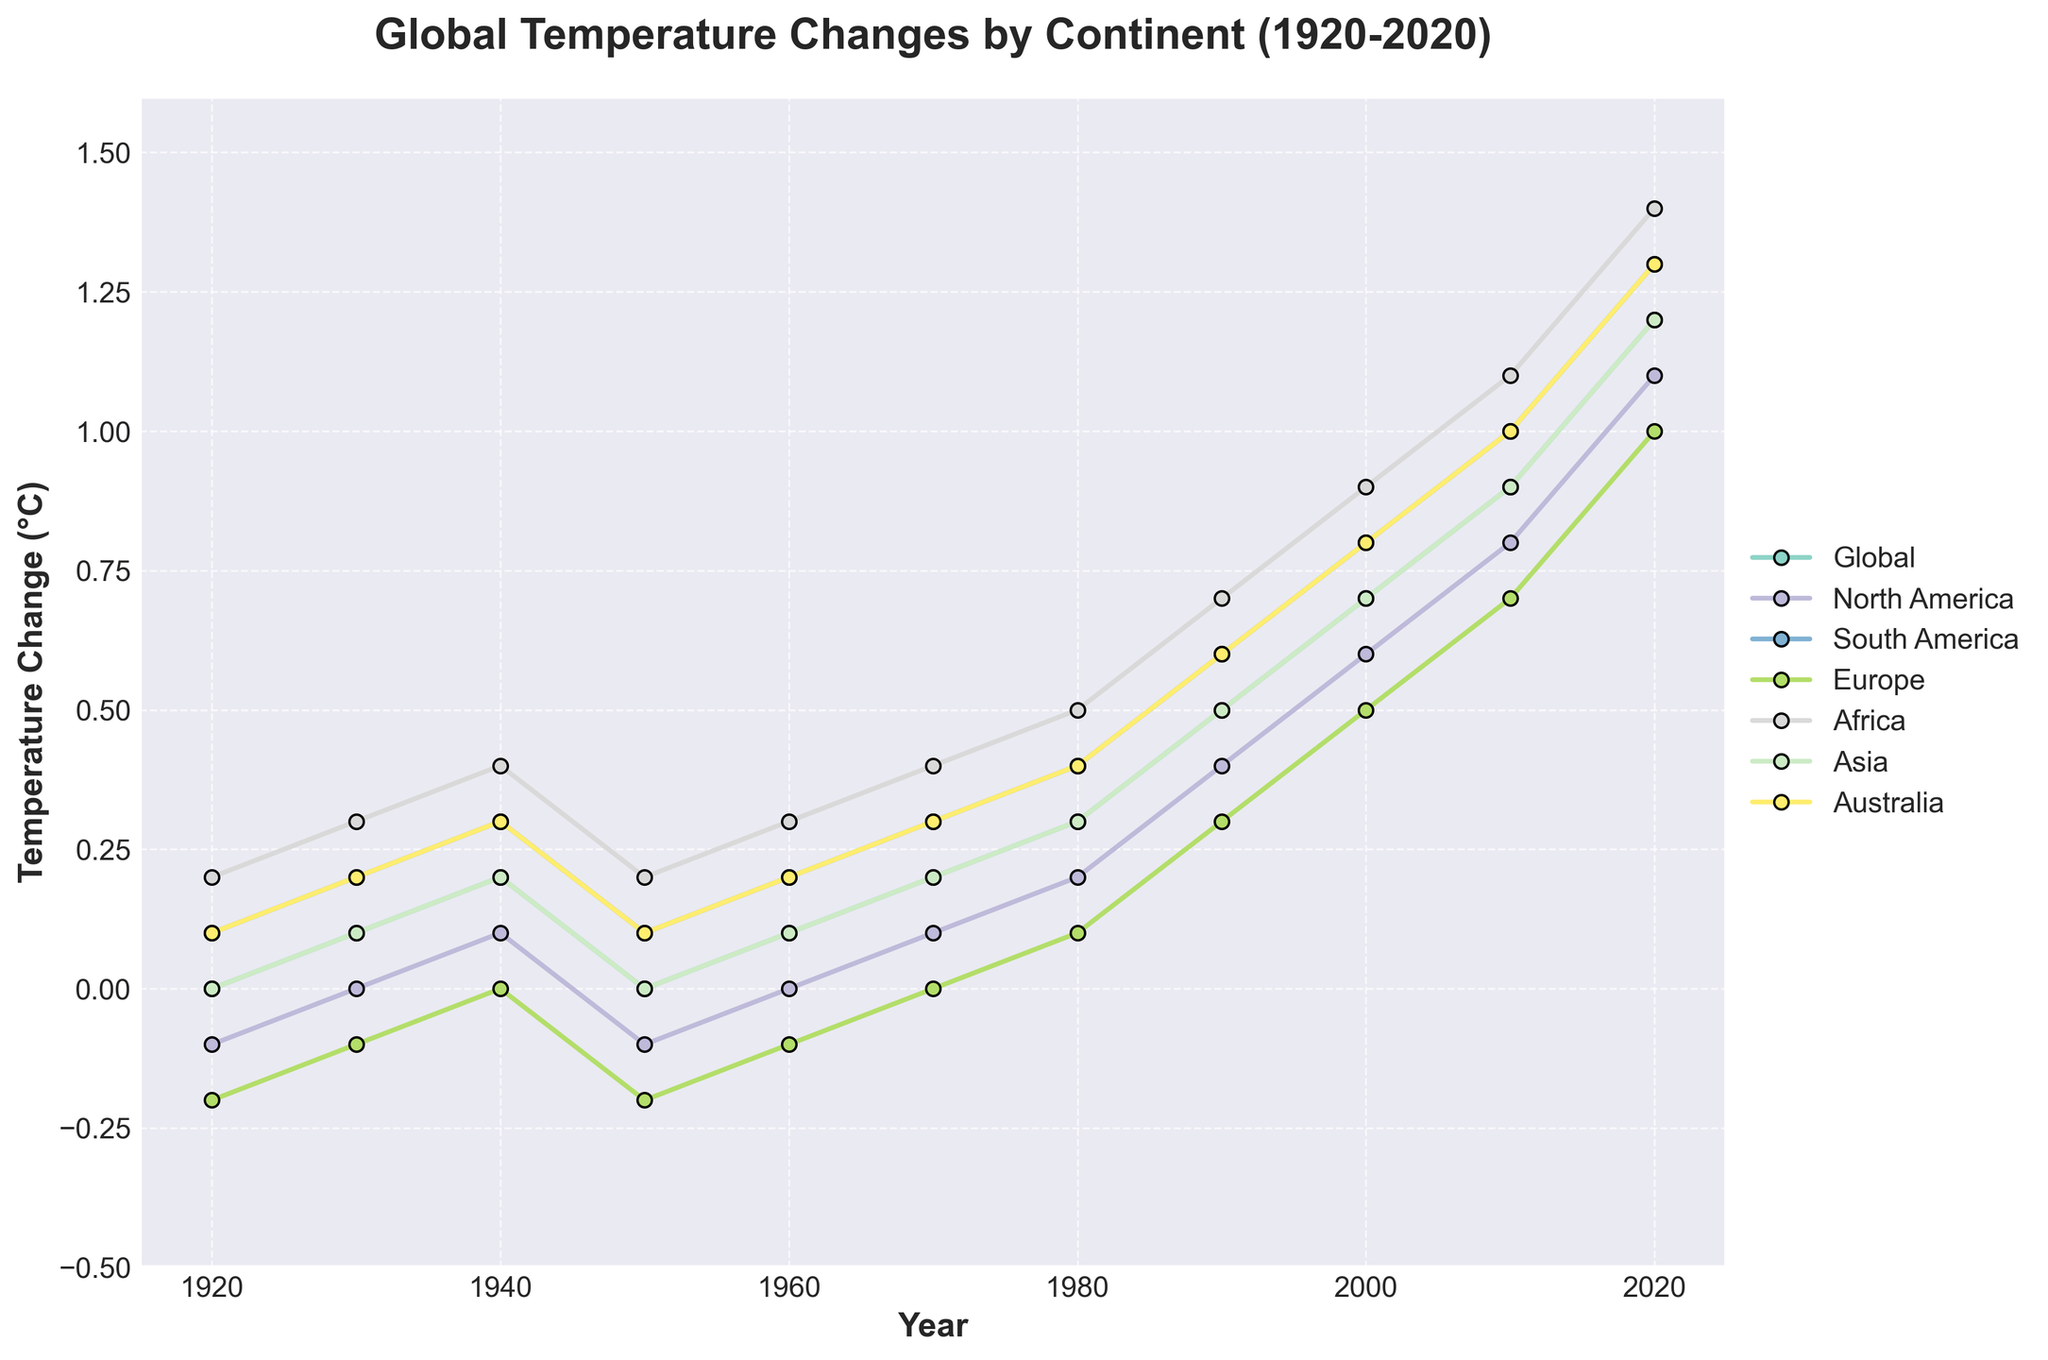Which continent had the highest temperature change in 2020? To find the answer, look at the temperature changes for all continents in 2020 and identify the highest value. From the figure, we see that Africa had a temperature change of 1.4°C, which is the highest.
Answer: Africa Between which decades did Europe see the most significant temperature increase? Examine the temperature changes for Europe across all decades. The temperature increased the most between 2000 (0.5°C) and 2010 (0.7°C), then between 2010 (0.7°C) and 2020 (1.0°C). The most significant increase was between 2010 and 2020, which was 0.3°C.
Answer: 2010-2020 What's the average temperature change in Asia between 1920 and 2020? First, sum up the temperature changes for Asia in all given years: 0.0 + 0.1 + 0.2 + 0.0 + 0.1 + 0.2 + 0.3 + 0.5 + 0.7 + 0.9 + 1.2 = 4.2. There are 11 data points, so the average is 4.2/11.
Answer: 0.38 By how much did the global average temperature change from 1920 to 2020? Subtract the global temperature change in 1920 (0.0°C) from that in 2020 (1.2°C).
Answer: 1.2°C Which year shows the sharpest global temperature increase compared to the previous decade? Calculate the decade-to-decade differences for the global average temperature:  
1930-1920: 0.1 - 0.0 = 0.1°C  
1940-1930: 0.2 - 0.1 = 0.1°C  
1950-1940: 0.0 - 0.2 = -0.2°C  
1960-1950: 0.1 - 0.0 = 0.1°C  
1970-1960: 0.2 - 0.1 = 0.1°C  
1980-1970: 0.3 - 0.2 = 0.1°C  
1990-1980: 0.5 - 0.3 = 0.2°C  
2000-1990: 0.7 - 0.5 = 0.2°C  
2010-2000: 0.9 - 0.7 = 0.2°C  
2020-2010: 1.2 - 0.9 = 0.3°C  
The sharpest increase was between 2010 and 2020.
Answer: 2010-2020 Compare the temperature changes between North America and South America in 1990. Which continent was warmer and by how much? Check the temperature changes for both continents in 1990: North America was 0.4°C, and South America was 0.6°C. South America was warmer by 0.2°C.
Answer: South America, 0.2°C 